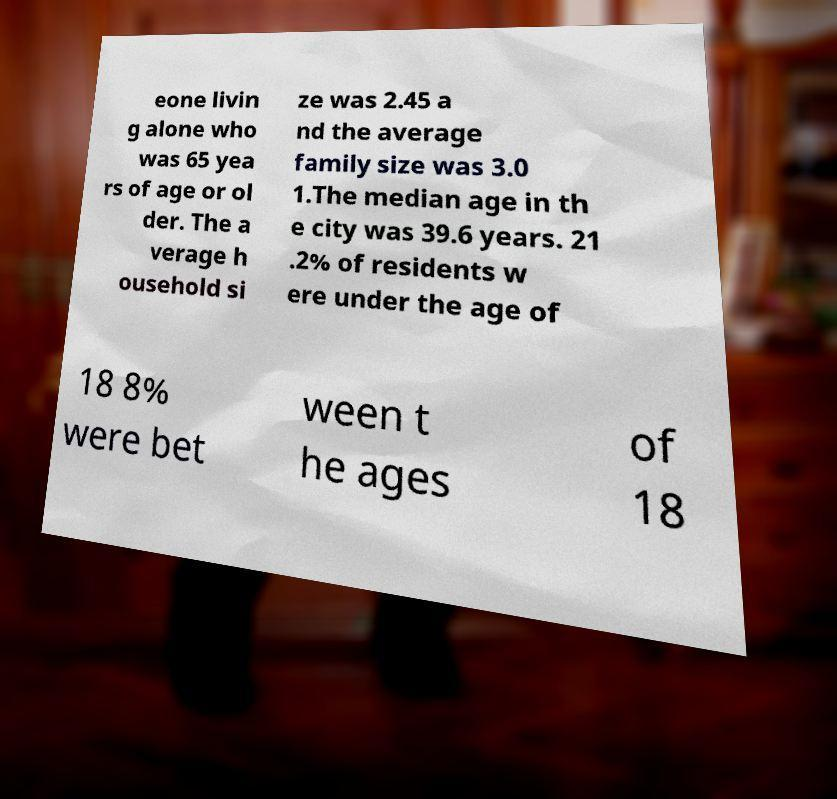For documentation purposes, I need the text within this image transcribed. Could you provide that? eone livin g alone who was 65 yea rs of age or ol der. The a verage h ousehold si ze was 2.45 a nd the average family size was 3.0 1.The median age in th e city was 39.6 years. 21 .2% of residents w ere under the age of 18 8% were bet ween t he ages of 18 